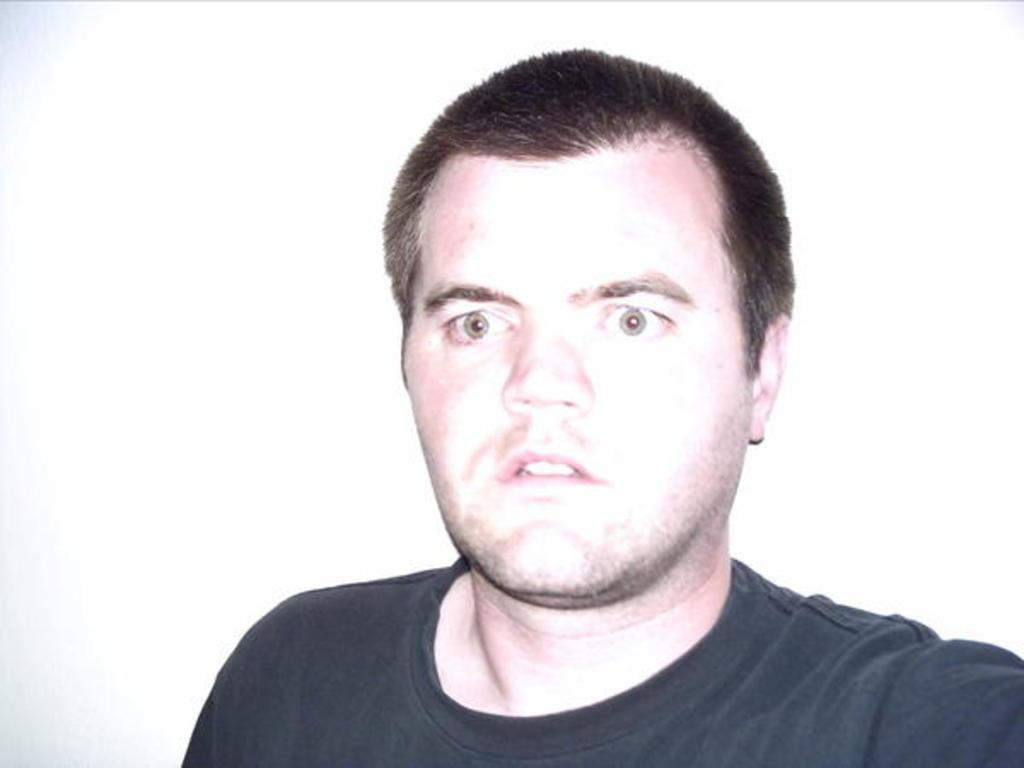Who is present in the image? There is a man in the image. What is the man wearing? The man is wearing a black t-shirt. What color is the background of the image? The background of the image is white. Can you see the man wearing a crown in the image? There is no crown present in the image; the man is wearing a black t-shirt. 